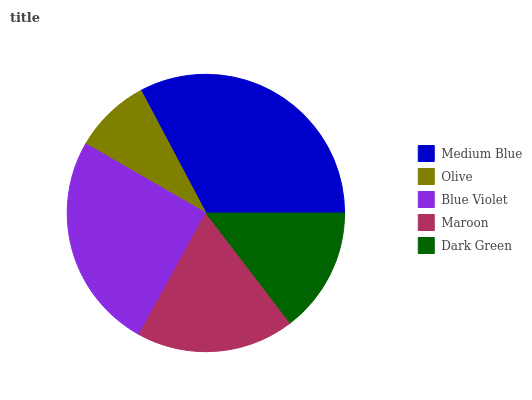Is Olive the minimum?
Answer yes or no. Yes. Is Medium Blue the maximum?
Answer yes or no. Yes. Is Blue Violet the minimum?
Answer yes or no. No. Is Blue Violet the maximum?
Answer yes or no. No. Is Blue Violet greater than Olive?
Answer yes or no. Yes. Is Olive less than Blue Violet?
Answer yes or no. Yes. Is Olive greater than Blue Violet?
Answer yes or no. No. Is Blue Violet less than Olive?
Answer yes or no. No. Is Maroon the high median?
Answer yes or no. Yes. Is Maroon the low median?
Answer yes or no. Yes. Is Medium Blue the high median?
Answer yes or no. No. Is Olive the low median?
Answer yes or no. No. 